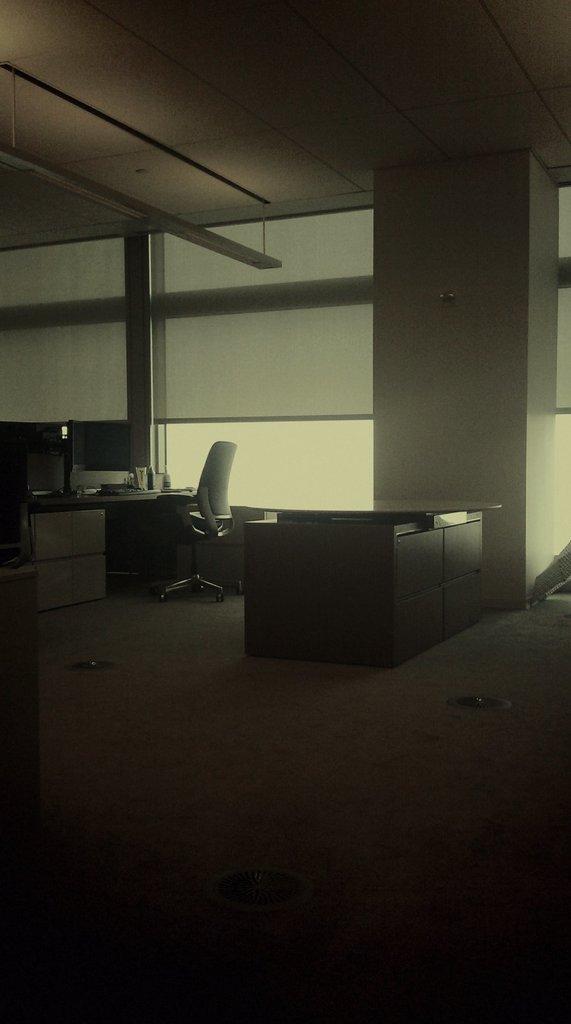Can you describe this image briefly? This is the picture taken in an office. This is floor on the floor there are tables, chair. Background of the chair is a glass window and a wall. 